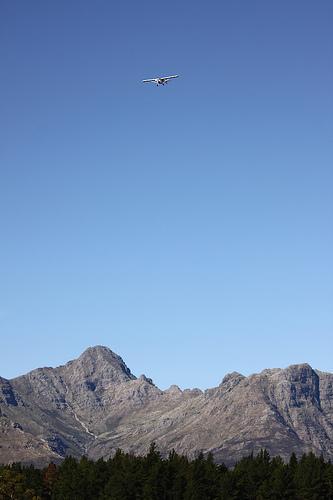How many planes are pictured?
Give a very brief answer. 1. 